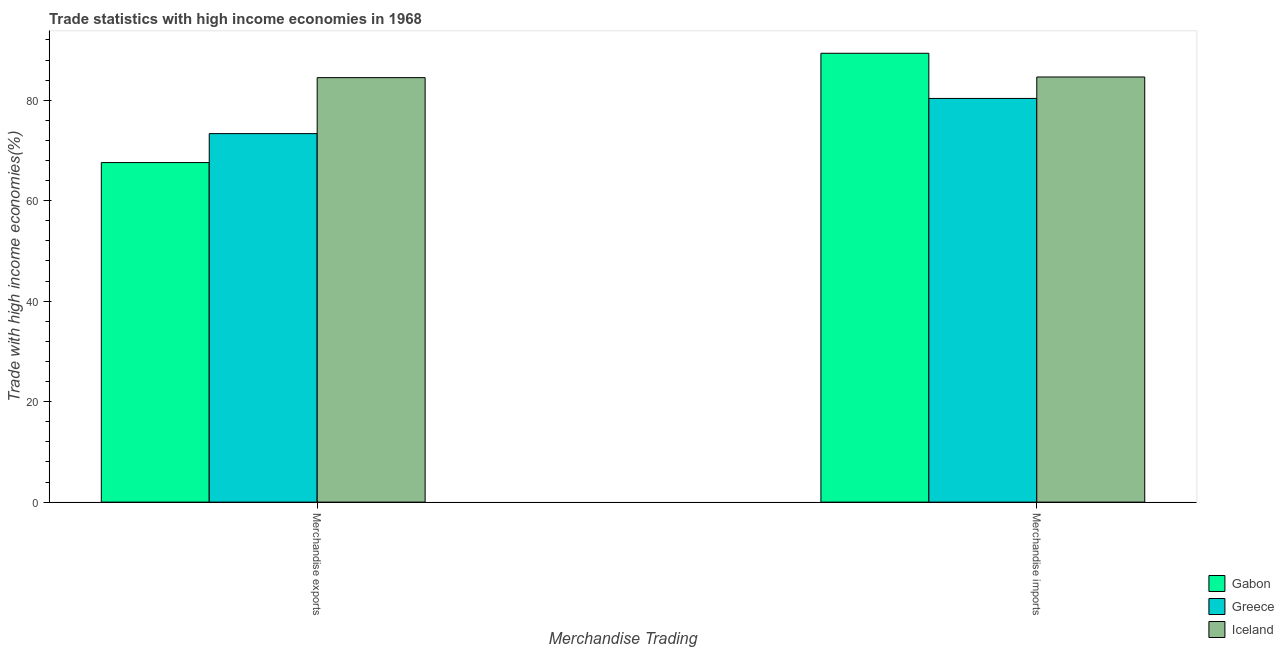How many bars are there on the 1st tick from the left?
Provide a succinct answer. 3. How many bars are there on the 1st tick from the right?
Make the answer very short. 3. What is the merchandise exports in Gabon?
Your answer should be compact. 67.59. Across all countries, what is the maximum merchandise imports?
Your answer should be very brief. 89.34. Across all countries, what is the minimum merchandise exports?
Offer a terse response. 67.59. In which country was the merchandise imports maximum?
Keep it short and to the point. Gabon. In which country was the merchandise imports minimum?
Give a very brief answer. Greece. What is the total merchandise exports in the graph?
Provide a short and direct response. 225.43. What is the difference between the merchandise exports in Gabon and that in Greece?
Your answer should be very brief. -5.76. What is the difference between the merchandise exports in Iceland and the merchandise imports in Gabon?
Provide a short and direct response. -4.85. What is the average merchandise exports per country?
Keep it short and to the point. 75.14. What is the difference between the merchandise exports and merchandise imports in Gabon?
Offer a very short reply. -21.75. In how many countries, is the merchandise exports greater than 48 %?
Make the answer very short. 3. What is the ratio of the merchandise imports in Iceland to that in Greece?
Give a very brief answer. 1.05. What does the 1st bar from the left in Merchandise exports represents?
Your answer should be compact. Gabon. What does the 3rd bar from the right in Merchandise imports represents?
Provide a short and direct response. Gabon. Are all the bars in the graph horizontal?
Offer a terse response. No. How many countries are there in the graph?
Your response must be concise. 3. What is the difference between two consecutive major ticks on the Y-axis?
Provide a short and direct response. 20. Are the values on the major ticks of Y-axis written in scientific E-notation?
Ensure brevity in your answer.  No. Does the graph contain any zero values?
Make the answer very short. No. Does the graph contain grids?
Provide a succinct answer. No. How are the legend labels stacked?
Your answer should be very brief. Vertical. What is the title of the graph?
Your answer should be very brief. Trade statistics with high income economies in 1968. What is the label or title of the X-axis?
Ensure brevity in your answer.  Merchandise Trading. What is the label or title of the Y-axis?
Make the answer very short. Trade with high income economies(%). What is the Trade with high income economies(%) in Gabon in Merchandise exports?
Keep it short and to the point. 67.59. What is the Trade with high income economies(%) of Greece in Merchandise exports?
Offer a terse response. 73.35. What is the Trade with high income economies(%) of Iceland in Merchandise exports?
Offer a terse response. 84.49. What is the Trade with high income economies(%) in Gabon in Merchandise imports?
Ensure brevity in your answer.  89.34. What is the Trade with high income economies(%) in Greece in Merchandise imports?
Give a very brief answer. 80.35. What is the Trade with high income economies(%) of Iceland in Merchandise imports?
Give a very brief answer. 84.62. Across all Merchandise Trading, what is the maximum Trade with high income economies(%) of Gabon?
Your answer should be very brief. 89.34. Across all Merchandise Trading, what is the maximum Trade with high income economies(%) in Greece?
Offer a terse response. 80.35. Across all Merchandise Trading, what is the maximum Trade with high income economies(%) in Iceland?
Make the answer very short. 84.62. Across all Merchandise Trading, what is the minimum Trade with high income economies(%) in Gabon?
Your answer should be compact. 67.59. Across all Merchandise Trading, what is the minimum Trade with high income economies(%) in Greece?
Give a very brief answer. 73.35. Across all Merchandise Trading, what is the minimum Trade with high income economies(%) of Iceland?
Give a very brief answer. 84.49. What is the total Trade with high income economies(%) of Gabon in the graph?
Your answer should be compact. 156.93. What is the total Trade with high income economies(%) in Greece in the graph?
Your answer should be compact. 153.7. What is the total Trade with high income economies(%) in Iceland in the graph?
Your answer should be compact. 169.11. What is the difference between the Trade with high income economies(%) of Gabon in Merchandise exports and that in Merchandise imports?
Provide a short and direct response. -21.75. What is the difference between the Trade with high income economies(%) of Greece in Merchandise exports and that in Merchandise imports?
Offer a very short reply. -7. What is the difference between the Trade with high income economies(%) in Iceland in Merchandise exports and that in Merchandise imports?
Keep it short and to the point. -0.13. What is the difference between the Trade with high income economies(%) in Gabon in Merchandise exports and the Trade with high income economies(%) in Greece in Merchandise imports?
Give a very brief answer. -12.77. What is the difference between the Trade with high income economies(%) of Gabon in Merchandise exports and the Trade with high income economies(%) of Iceland in Merchandise imports?
Your answer should be compact. -17.03. What is the difference between the Trade with high income economies(%) in Greece in Merchandise exports and the Trade with high income economies(%) in Iceland in Merchandise imports?
Ensure brevity in your answer.  -11.27. What is the average Trade with high income economies(%) in Gabon per Merchandise Trading?
Your response must be concise. 78.46. What is the average Trade with high income economies(%) in Greece per Merchandise Trading?
Ensure brevity in your answer.  76.85. What is the average Trade with high income economies(%) of Iceland per Merchandise Trading?
Your response must be concise. 84.56. What is the difference between the Trade with high income economies(%) in Gabon and Trade with high income economies(%) in Greece in Merchandise exports?
Provide a succinct answer. -5.76. What is the difference between the Trade with high income economies(%) in Gabon and Trade with high income economies(%) in Iceland in Merchandise exports?
Offer a very short reply. -16.91. What is the difference between the Trade with high income economies(%) in Greece and Trade with high income economies(%) in Iceland in Merchandise exports?
Ensure brevity in your answer.  -11.14. What is the difference between the Trade with high income economies(%) in Gabon and Trade with high income economies(%) in Greece in Merchandise imports?
Your answer should be compact. 8.99. What is the difference between the Trade with high income economies(%) in Gabon and Trade with high income economies(%) in Iceland in Merchandise imports?
Keep it short and to the point. 4.72. What is the difference between the Trade with high income economies(%) in Greece and Trade with high income economies(%) in Iceland in Merchandise imports?
Provide a succinct answer. -4.27. What is the ratio of the Trade with high income economies(%) of Gabon in Merchandise exports to that in Merchandise imports?
Your response must be concise. 0.76. What is the ratio of the Trade with high income economies(%) in Greece in Merchandise exports to that in Merchandise imports?
Offer a very short reply. 0.91. What is the difference between the highest and the second highest Trade with high income economies(%) in Gabon?
Provide a short and direct response. 21.75. What is the difference between the highest and the second highest Trade with high income economies(%) of Greece?
Offer a terse response. 7. What is the difference between the highest and the second highest Trade with high income economies(%) of Iceland?
Make the answer very short. 0.13. What is the difference between the highest and the lowest Trade with high income economies(%) in Gabon?
Ensure brevity in your answer.  21.75. What is the difference between the highest and the lowest Trade with high income economies(%) in Greece?
Offer a very short reply. 7. What is the difference between the highest and the lowest Trade with high income economies(%) of Iceland?
Your response must be concise. 0.13. 